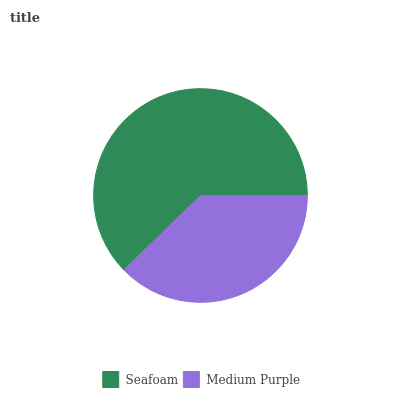Is Medium Purple the minimum?
Answer yes or no. Yes. Is Seafoam the maximum?
Answer yes or no. Yes. Is Medium Purple the maximum?
Answer yes or no. No. Is Seafoam greater than Medium Purple?
Answer yes or no. Yes. Is Medium Purple less than Seafoam?
Answer yes or no. Yes. Is Medium Purple greater than Seafoam?
Answer yes or no. No. Is Seafoam less than Medium Purple?
Answer yes or no. No. Is Seafoam the high median?
Answer yes or no. Yes. Is Medium Purple the low median?
Answer yes or no. Yes. Is Medium Purple the high median?
Answer yes or no. No. Is Seafoam the low median?
Answer yes or no. No. 